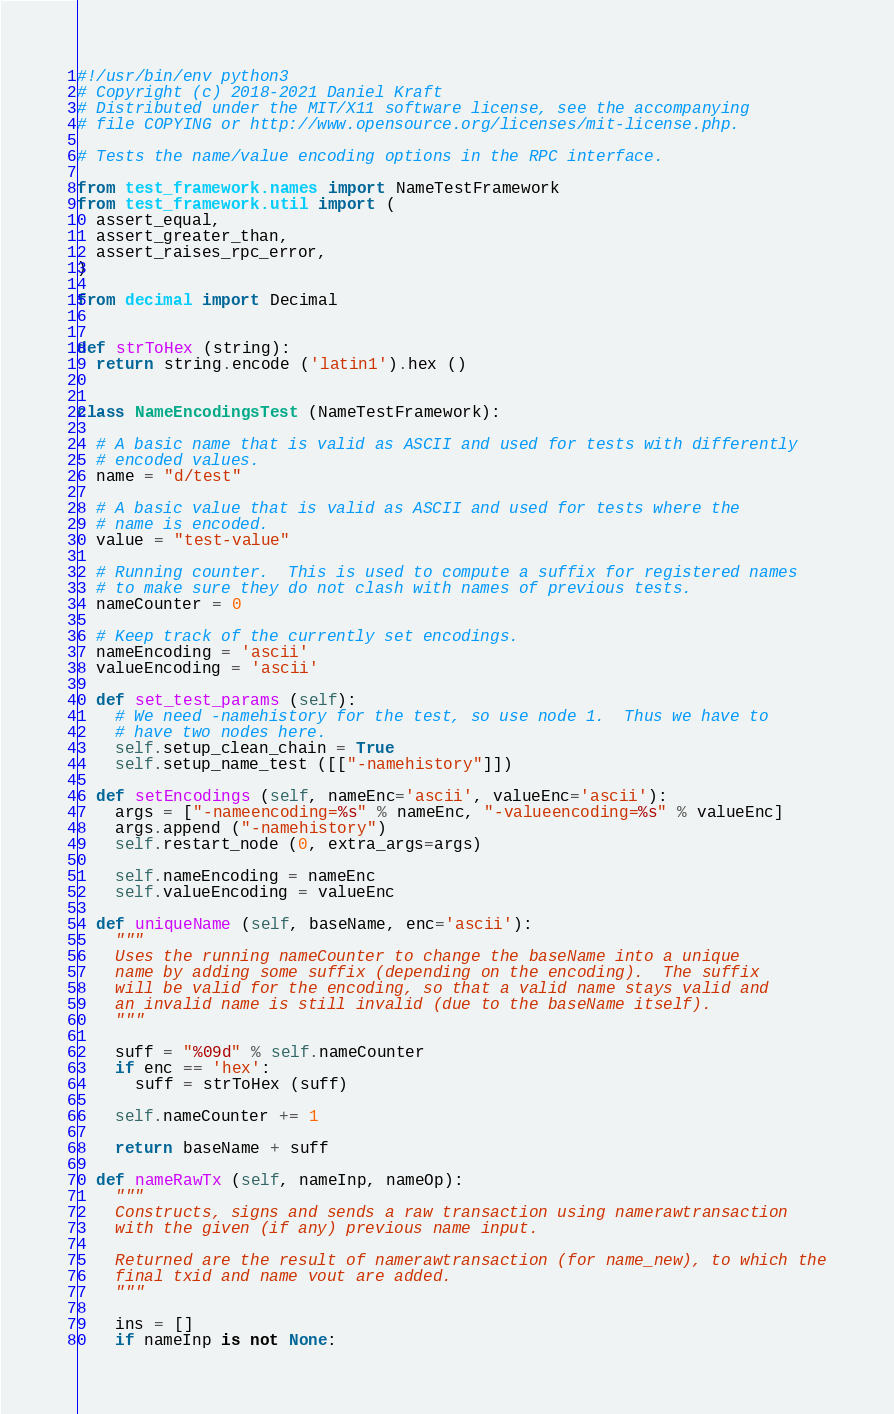<code> <loc_0><loc_0><loc_500><loc_500><_Python_>#!/usr/bin/env python3
# Copyright (c) 2018-2021 Daniel Kraft
# Distributed under the MIT/X11 software license, see the accompanying
# file COPYING or http://www.opensource.org/licenses/mit-license.php.

# Tests the name/value encoding options in the RPC interface.

from test_framework.names import NameTestFramework
from test_framework.util import (
  assert_equal,
  assert_greater_than,
  assert_raises_rpc_error,
)

from decimal import Decimal


def strToHex (string):
  return string.encode ('latin1').hex ()


class NameEncodingsTest (NameTestFramework):

  # A basic name that is valid as ASCII and used for tests with differently
  # encoded values.
  name = "d/test"

  # A basic value that is valid as ASCII and used for tests where the
  # name is encoded.
  value = "test-value"

  # Running counter.  This is used to compute a suffix for registered names
  # to make sure they do not clash with names of previous tests.
  nameCounter = 0

  # Keep track of the currently set encodings.
  nameEncoding = 'ascii'
  valueEncoding = 'ascii'

  def set_test_params (self):
    # We need -namehistory for the test, so use node 1.  Thus we have to
    # have two nodes here.
    self.setup_clean_chain = True
    self.setup_name_test ([["-namehistory"]])

  def setEncodings (self, nameEnc='ascii', valueEnc='ascii'):
    args = ["-nameencoding=%s" % nameEnc, "-valueencoding=%s" % valueEnc]
    args.append ("-namehistory")
    self.restart_node (0, extra_args=args)

    self.nameEncoding = nameEnc
    self.valueEncoding = valueEnc

  def uniqueName (self, baseName, enc='ascii'):
    """
    Uses the running nameCounter to change the baseName into a unique
    name by adding some suffix (depending on the encoding).  The suffix
    will be valid for the encoding, so that a valid name stays valid and
    an invalid name is still invalid (due to the baseName itself).
    """

    suff = "%09d" % self.nameCounter
    if enc == 'hex':
      suff = strToHex (suff)

    self.nameCounter += 1

    return baseName + suff

  def nameRawTx (self, nameInp, nameOp):
    """
    Constructs, signs and sends a raw transaction using namerawtransaction
    with the given (if any) previous name input.

    Returned are the result of namerawtransaction (for name_new), to which the
    final txid and name vout are added.
    """

    ins = []
    if nameInp is not None:</code> 